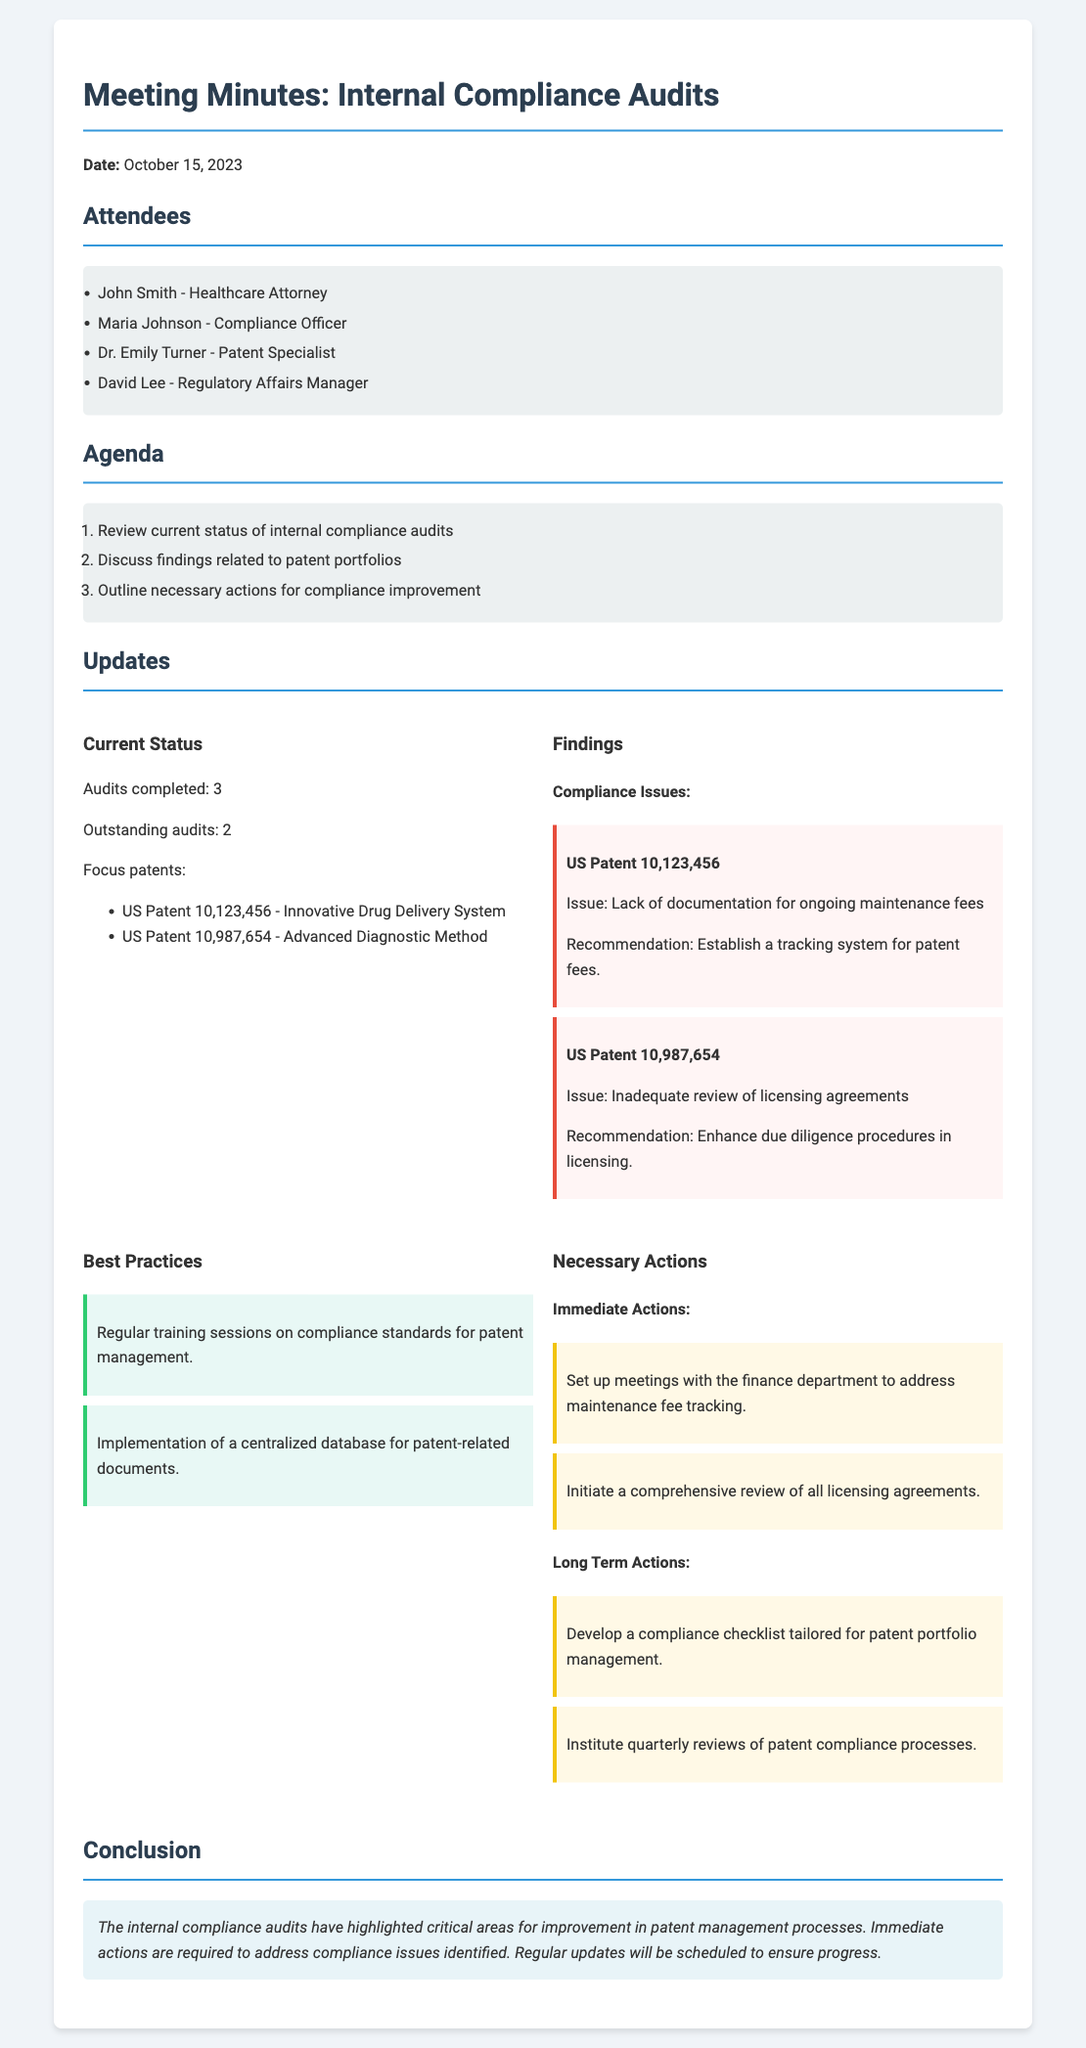what is the date of the meeting? The date of the meeting is stated clearly at the beginning of the document.
Answer: October 15, 2023 how many audits have been completed? The document specifies the status of audits, detailing how many have been finished.
Answer: 3 what is the issue identified with US Patent 10,123,456? The document outlines the specific compliance issue related to this patent.
Answer: Lack of documentation for ongoing maintenance fees who is the Compliance Officer present in the meeting? The document lists the attendees, including their respective roles.
Answer: Maria Johnson what is one immediate action proposed? The document outlines necessary actions, indicating what needs to be addressed immediately.
Answer: Set up meetings with the finance department to address maintenance fee tracking how many outstanding audits are mentioned? The document provides information on the number of audits that are still pending.
Answer: 2 what best practice is recommended for patent management? The document highlights best practices, one of which pertains to compliance training sessions.
Answer: Regular training sessions on compliance standards for patent management what is the focus patent listed for review? The document identifies specific patents that are a focus of the internal audits.
Answer: US Patent 10,123,456 - Innovative Drug Delivery System what is the conclusion regarding the compliance audits? The conclusion reflects on the findings and future actions based on audit results.
Answer: Immediate actions are required to address compliance issues identified 